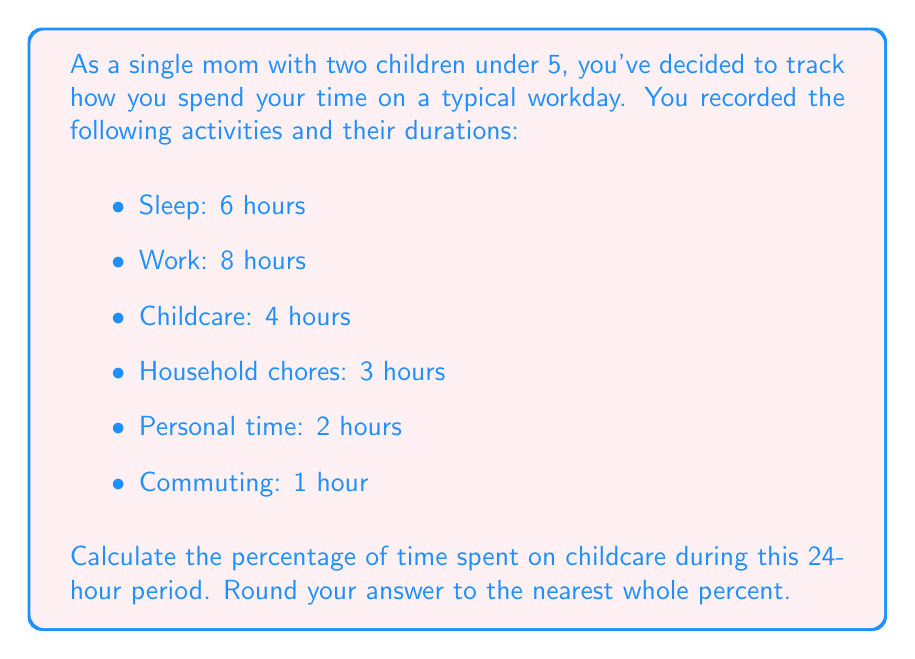Provide a solution to this math problem. To solve this problem, we'll follow these steps:

1. Calculate the total hours in the day:
   $$6 + 8 + 4 + 3 + 2 + 1 = 24\text{ hours}$$

2. Identify the time spent on childcare:
   $$4\text{ hours}$$

3. Calculate the percentage using the formula:
   $$\text{Percentage} = \frac{\text{Part}}{\text{Whole}} \times 100\%$$

4. Plug in the values:
   $$\text{Percentage} = \frac{4\text{ hours}}{24\text{ hours}} \times 100\%$$

5. Simplify the fraction:
   $$\text{Percentage} = \frac{1}{6} \times 100\%$$

6. Perform the multiplication:
   $$\text{Percentage} = 0.1666... \times 100\% = 16.66...\%$$

7. Round to the nearest whole percent:
   $$16.66...\% \approx 17\%$$
Answer: 17% 